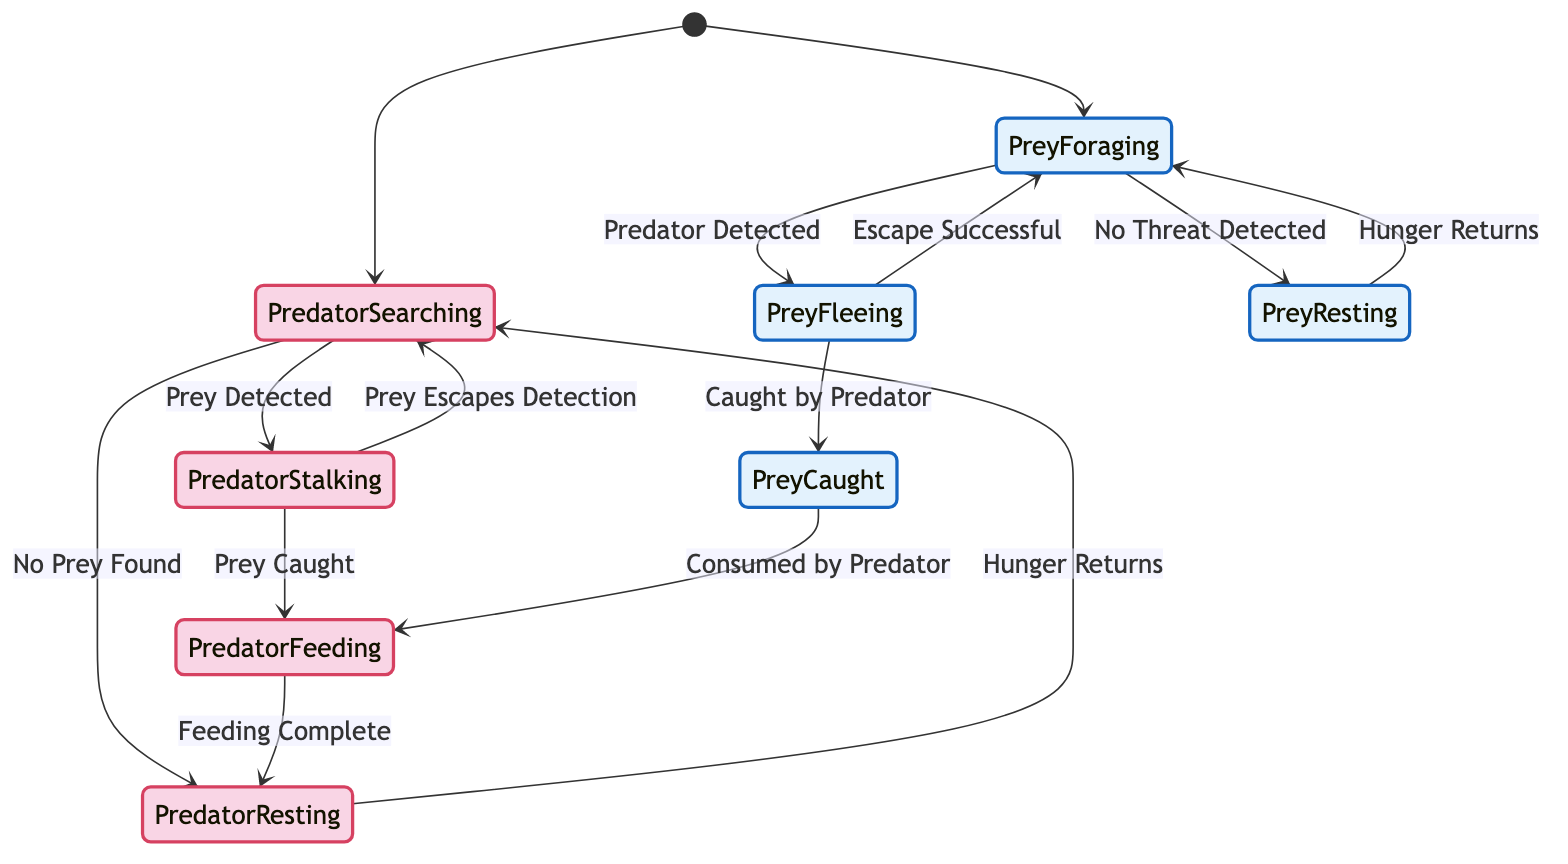What are the initial states in the diagram? The diagram begins with two initial states that the predator and prey can be in, which are "Predator Searching" and "Prey Foraging."
Answer: Predator Searching, Prey Foraging How many total states are there in the diagram? By counting, there are eight distinct states in the diagram: "Predator Searching," "Predator Stalking," "Predator Feeding," "Predator Resting," "Prey Foraging," "Prey Fleeing," "Prey Resting," and "Prey Caught."
Answer: Eight What happens when the "Prey Detected" action occurs? When the "Prey Detected" action occurs, the state changes from "Predator Searching" to "Predator Stalking." This signifies that the predator has found a potential prey.
Answer: Predator Stalking In which states can the prey be after detecting a predator? After detecting a predator, the prey enters the "Prey Fleeing" state as a reaction to the threat.
Answer: Prey Fleeing If the predator is in the "Predator Feeding" state, what is the next state after the action "Feeding Complete"? The next state after the action "Feeding Complete" from "Predator Feeding" is "Predator Resting," indicating the predator has finished eating.
Answer: Predator Resting What transition occurs from "Prey Fleeing" state? From the "Prey Fleeing" state, there are two possible transitions based on the outcomes: it can either move to "Prey Foraging" if the "Escape Successful" action occurs or to "Prey Caught" if it is "Caught by Predator."
Answer: Prey Foraging, Prey Caught What state follows "Predator Stalking" if the prey escapes detection? If the prey escapes detection while the predator is stalking, the state returns to "Predator Searching." This indicates the predator resumes searching for prey.
Answer: Predator Searching Which state represents the prey being consumed? The state that shows the prey being consumed by the predator is labeled "Prey Caught." This state indicates the prey has been successfully caught.
Answer: Prey Caught 